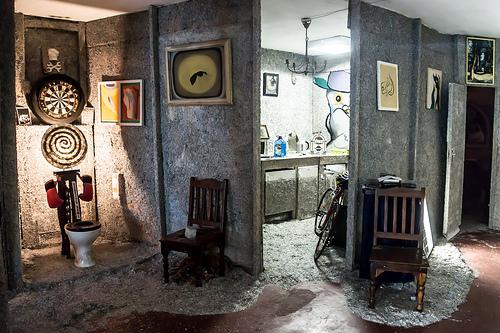What type of object is hanging from the ceiling? A light hanging from the ceiling. Create a product advertisement phrase for the bottle on the counter. Discover the refreshing taste of our blue bottle drink, perfectly placed on your counter for convenience and enjoyment. Name all the objects on the wall. Pictures, dartboard, and drawing. In a brief phrase, describe the location of the toilet bowl. Toilet bowl in the corner. For the visual entailment task, describe a positive relationship between a picture and a wall. The picture is hung on the wall. 